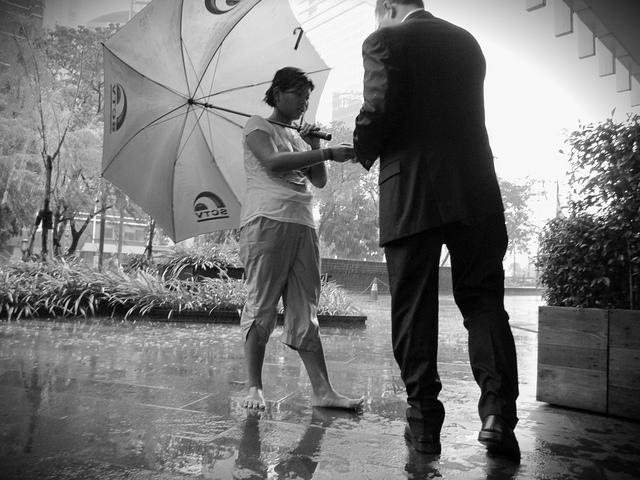What is she giving the man? money 